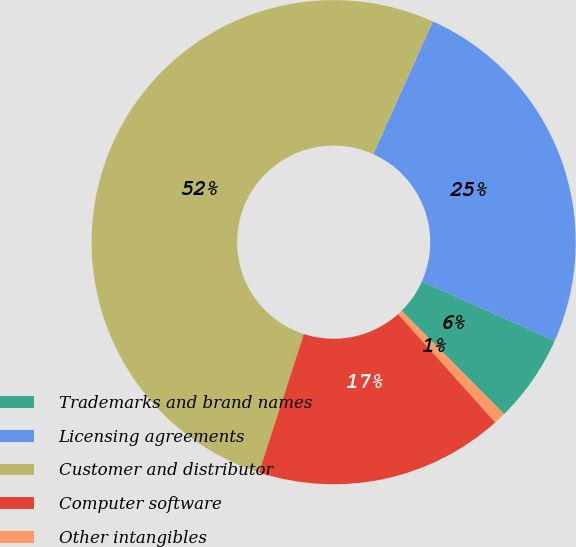Convert chart. <chart><loc_0><loc_0><loc_500><loc_500><pie_chart><fcel>Trademarks and brand names<fcel>Licensing agreements<fcel>Customer and distributor<fcel>Computer software<fcel>Other intangibles<nl><fcel>5.89%<fcel>24.96%<fcel>51.73%<fcel>16.63%<fcel>0.79%<nl></chart> 